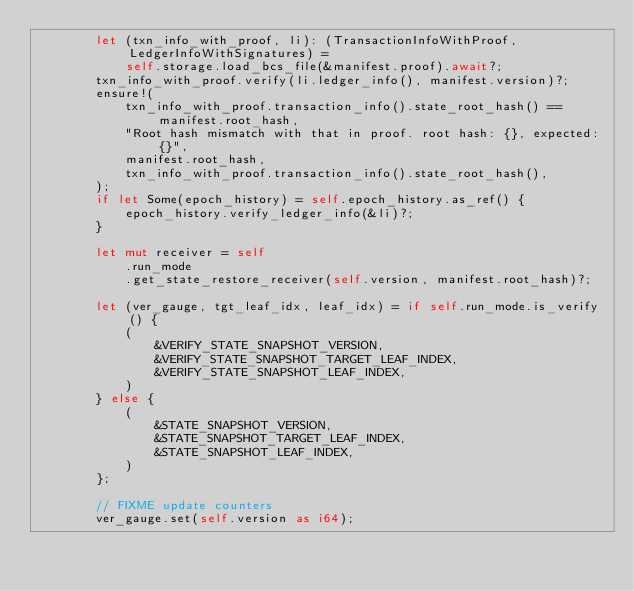<code> <loc_0><loc_0><loc_500><loc_500><_Rust_>        let (txn_info_with_proof, li): (TransactionInfoWithProof, LedgerInfoWithSignatures) =
            self.storage.load_bcs_file(&manifest.proof).await?;
        txn_info_with_proof.verify(li.ledger_info(), manifest.version)?;
        ensure!(
            txn_info_with_proof.transaction_info().state_root_hash() == manifest.root_hash,
            "Root hash mismatch with that in proof. root hash: {}, expected: {}",
            manifest.root_hash,
            txn_info_with_proof.transaction_info().state_root_hash(),
        );
        if let Some(epoch_history) = self.epoch_history.as_ref() {
            epoch_history.verify_ledger_info(&li)?;
        }

        let mut receiver = self
            .run_mode
            .get_state_restore_receiver(self.version, manifest.root_hash)?;

        let (ver_gauge, tgt_leaf_idx, leaf_idx) = if self.run_mode.is_verify() {
            (
                &VERIFY_STATE_SNAPSHOT_VERSION,
                &VERIFY_STATE_SNAPSHOT_TARGET_LEAF_INDEX,
                &VERIFY_STATE_SNAPSHOT_LEAF_INDEX,
            )
        } else {
            (
                &STATE_SNAPSHOT_VERSION,
                &STATE_SNAPSHOT_TARGET_LEAF_INDEX,
                &STATE_SNAPSHOT_LEAF_INDEX,
            )
        };

        // FIXME update counters
        ver_gauge.set(self.version as i64);</code> 